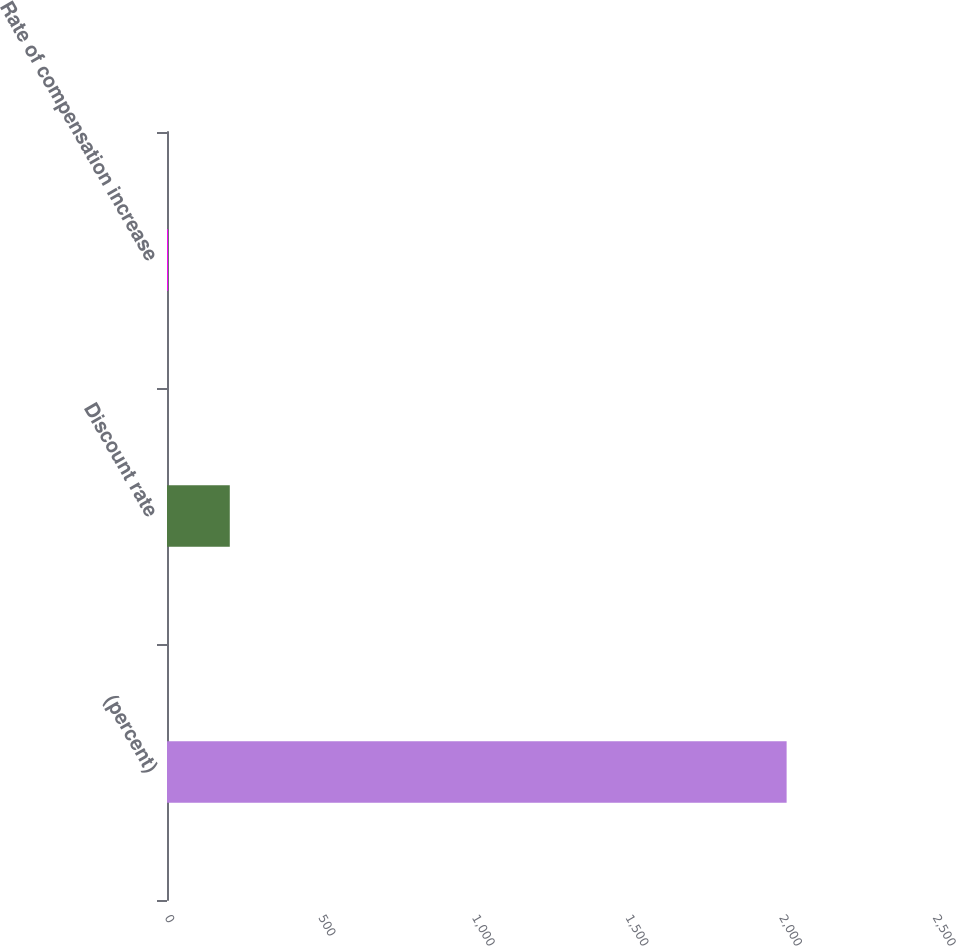Convert chart to OTSL. <chart><loc_0><loc_0><loc_500><loc_500><bar_chart><fcel>(percent)<fcel>Discount rate<fcel>Rate of compensation increase<nl><fcel>2017<fcel>204.38<fcel>2.98<nl></chart> 